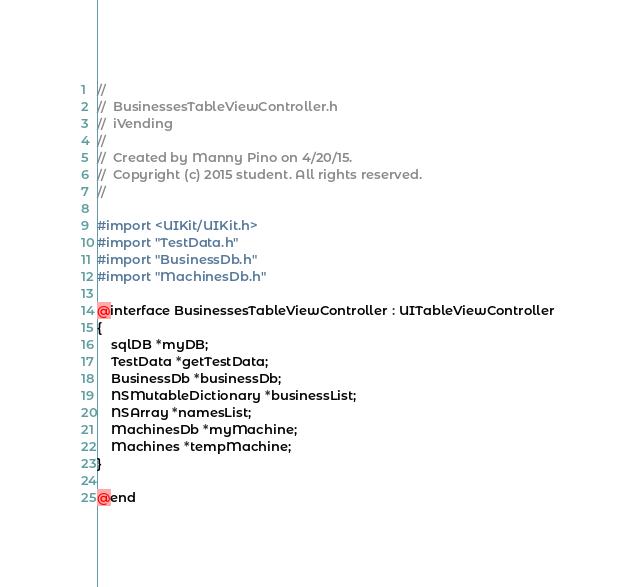<code> <loc_0><loc_0><loc_500><loc_500><_C_>//
//  BusinessesTableViewController.h
//  iVending
//
//  Created by Manny Pino on 4/20/15.
//  Copyright (c) 2015 student. All rights reserved.
//

#import <UIKit/UIKit.h>
#import "TestData.h"
#import "BusinessDb.h"
#import "MachinesDb.h"

@interface BusinessesTableViewController : UITableViewController
{
    sqlDB *myDB;
    TestData *getTestData;
    BusinessDb *businessDb;
    NSMutableDictionary *businessList;
    NSArray *namesList;
    MachinesDb *myMachine;
    Machines *tempMachine;
}

@end
</code> 